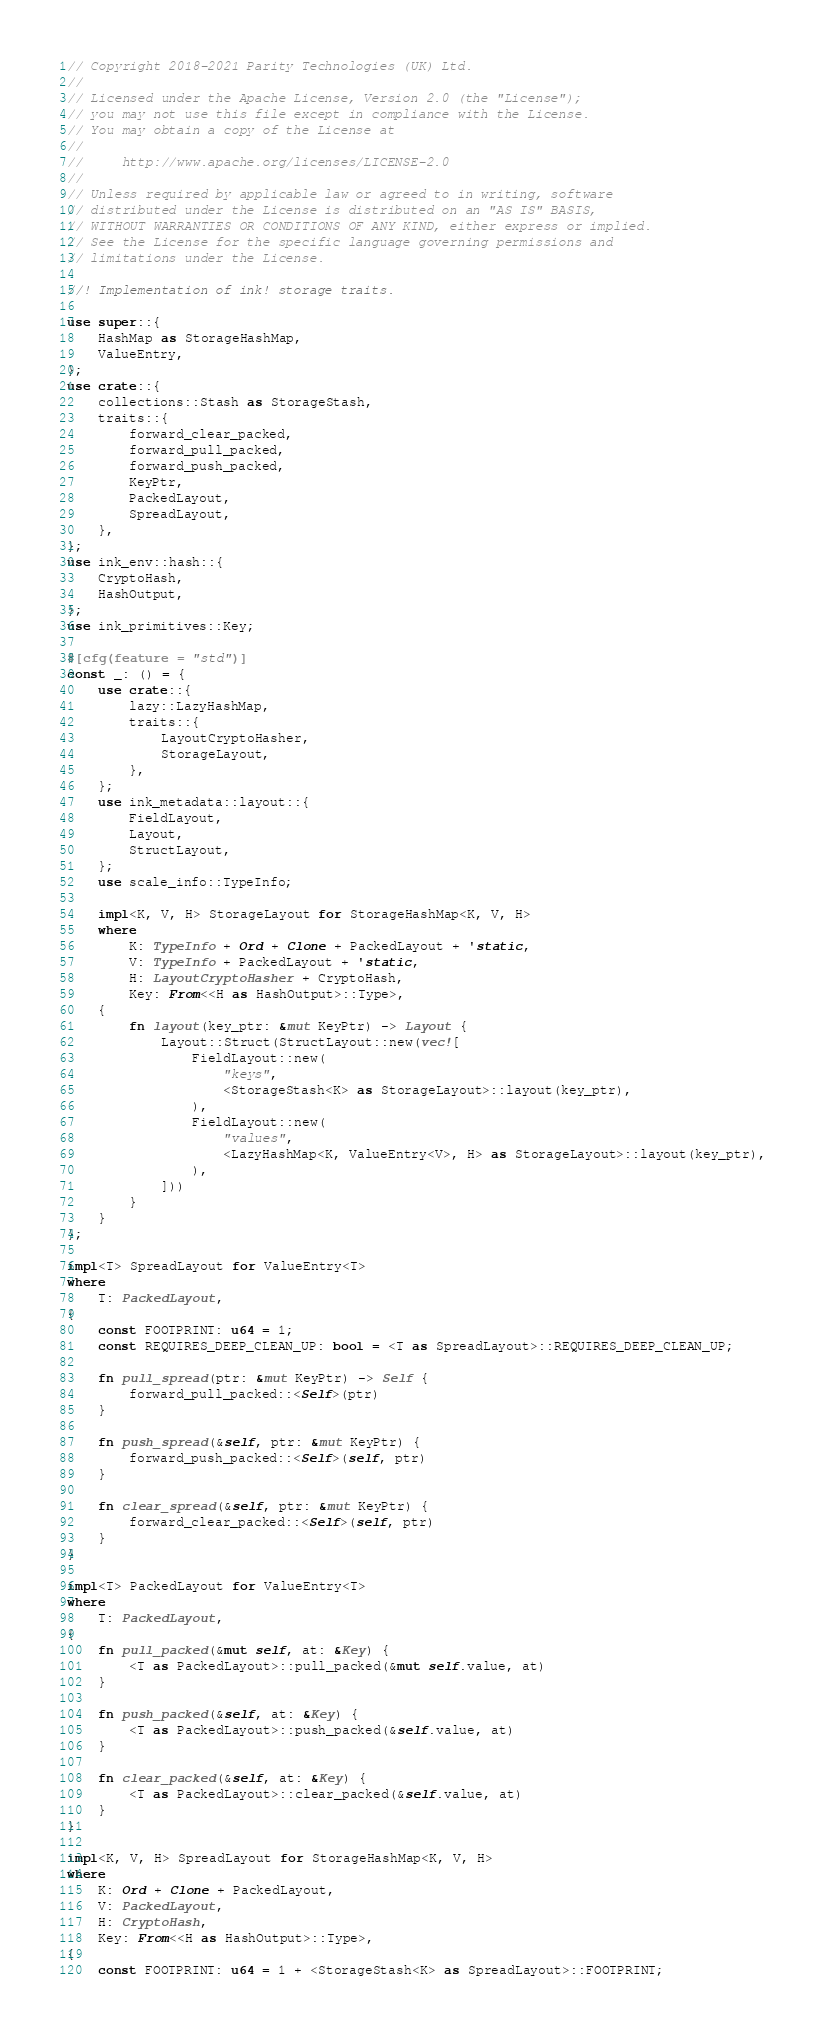Convert code to text. <code><loc_0><loc_0><loc_500><loc_500><_Rust_>// Copyright 2018-2021 Parity Technologies (UK) Ltd.
//
// Licensed under the Apache License, Version 2.0 (the "License");
// you may not use this file except in compliance with the License.
// You may obtain a copy of the License at
//
//     http://www.apache.org/licenses/LICENSE-2.0
//
// Unless required by applicable law or agreed to in writing, software
// distributed under the License is distributed on an "AS IS" BASIS,
// WITHOUT WARRANTIES OR CONDITIONS OF ANY KIND, either express or implied.
// See the License for the specific language governing permissions and
// limitations under the License.

//! Implementation of ink! storage traits.

use super::{
    HashMap as StorageHashMap,
    ValueEntry,
};
use crate::{
    collections::Stash as StorageStash,
    traits::{
        forward_clear_packed,
        forward_pull_packed,
        forward_push_packed,
        KeyPtr,
        PackedLayout,
        SpreadLayout,
    },
};
use ink_env::hash::{
    CryptoHash,
    HashOutput,
};
use ink_primitives::Key;

#[cfg(feature = "std")]
const _: () = {
    use crate::{
        lazy::LazyHashMap,
        traits::{
            LayoutCryptoHasher,
            StorageLayout,
        },
    };
    use ink_metadata::layout::{
        FieldLayout,
        Layout,
        StructLayout,
    };
    use scale_info::TypeInfo;

    impl<K, V, H> StorageLayout for StorageHashMap<K, V, H>
    where
        K: TypeInfo + Ord + Clone + PackedLayout + 'static,
        V: TypeInfo + PackedLayout + 'static,
        H: LayoutCryptoHasher + CryptoHash,
        Key: From<<H as HashOutput>::Type>,
    {
        fn layout(key_ptr: &mut KeyPtr) -> Layout {
            Layout::Struct(StructLayout::new(vec![
                FieldLayout::new(
                    "keys",
                    <StorageStash<K> as StorageLayout>::layout(key_ptr),
                ),
                FieldLayout::new(
                    "values",
                    <LazyHashMap<K, ValueEntry<V>, H> as StorageLayout>::layout(key_ptr),
                ),
            ]))
        }
    }
};

impl<T> SpreadLayout for ValueEntry<T>
where
    T: PackedLayout,
{
    const FOOTPRINT: u64 = 1;
    const REQUIRES_DEEP_CLEAN_UP: bool = <T as SpreadLayout>::REQUIRES_DEEP_CLEAN_UP;

    fn pull_spread(ptr: &mut KeyPtr) -> Self {
        forward_pull_packed::<Self>(ptr)
    }

    fn push_spread(&self, ptr: &mut KeyPtr) {
        forward_push_packed::<Self>(self, ptr)
    }

    fn clear_spread(&self, ptr: &mut KeyPtr) {
        forward_clear_packed::<Self>(self, ptr)
    }
}

impl<T> PackedLayout for ValueEntry<T>
where
    T: PackedLayout,
{
    fn pull_packed(&mut self, at: &Key) {
        <T as PackedLayout>::pull_packed(&mut self.value, at)
    }

    fn push_packed(&self, at: &Key) {
        <T as PackedLayout>::push_packed(&self.value, at)
    }

    fn clear_packed(&self, at: &Key) {
        <T as PackedLayout>::clear_packed(&self.value, at)
    }
}

impl<K, V, H> SpreadLayout for StorageHashMap<K, V, H>
where
    K: Ord + Clone + PackedLayout,
    V: PackedLayout,
    H: CryptoHash,
    Key: From<<H as HashOutput>::Type>,
{
    const FOOTPRINT: u64 = 1 + <StorageStash<K> as SpreadLayout>::FOOTPRINT;
</code> 